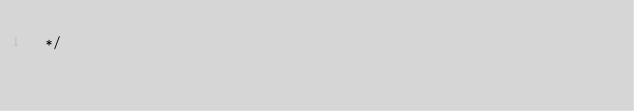<code> <loc_0><loc_0><loc_500><loc_500><_CSS_> */</code> 